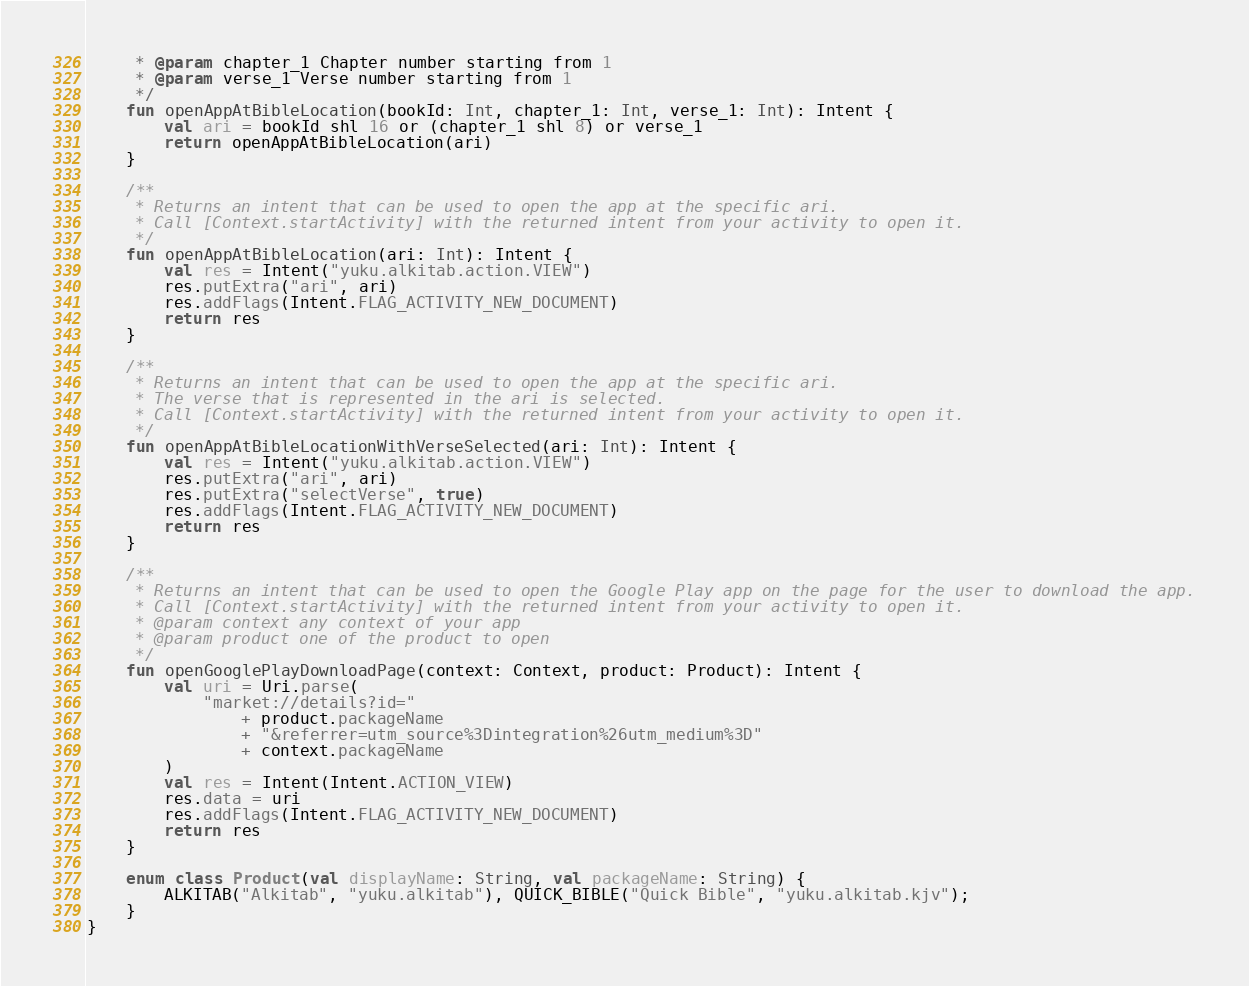<code> <loc_0><loc_0><loc_500><loc_500><_Kotlin_>     * @param chapter_1 Chapter number starting from 1
     * @param verse_1 Verse number starting from 1
     */
    fun openAppAtBibleLocation(bookId: Int, chapter_1: Int, verse_1: Int): Intent {
        val ari = bookId shl 16 or (chapter_1 shl 8) or verse_1
        return openAppAtBibleLocation(ari)
    }

    /**
     * Returns an intent that can be used to open the app at the specific ari.
     * Call [Context.startActivity] with the returned intent from your activity to open it.
     */
    fun openAppAtBibleLocation(ari: Int): Intent {
        val res = Intent("yuku.alkitab.action.VIEW")
        res.putExtra("ari", ari)
        res.addFlags(Intent.FLAG_ACTIVITY_NEW_DOCUMENT)
        return res
    }

    /**
     * Returns an intent that can be used to open the app at the specific ari.
     * The verse that is represented in the ari is selected.
     * Call [Context.startActivity] with the returned intent from your activity to open it.
     */
    fun openAppAtBibleLocationWithVerseSelected(ari: Int): Intent {
        val res = Intent("yuku.alkitab.action.VIEW")
        res.putExtra("ari", ari)
        res.putExtra("selectVerse", true)
        res.addFlags(Intent.FLAG_ACTIVITY_NEW_DOCUMENT)
        return res
    }

    /**
     * Returns an intent that can be used to open the Google Play app on the page for the user to download the app.
     * Call [Context.startActivity] with the returned intent from your activity to open it.
     * @param context any context of your app
     * @param product one of the product to open
     */
    fun openGooglePlayDownloadPage(context: Context, product: Product): Intent {
        val uri = Uri.parse(
            "market://details?id="
                + product.packageName
                + "&referrer=utm_source%3Dintegration%26utm_medium%3D"
                + context.packageName
        )
        val res = Intent(Intent.ACTION_VIEW)
        res.data = uri
        res.addFlags(Intent.FLAG_ACTIVITY_NEW_DOCUMENT)
        return res
    }

    enum class Product(val displayName: String, val packageName: String) {
        ALKITAB("Alkitab", "yuku.alkitab"), QUICK_BIBLE("Quick Bible", "yuku.alkitab.kjv");
    }
}
</code> 